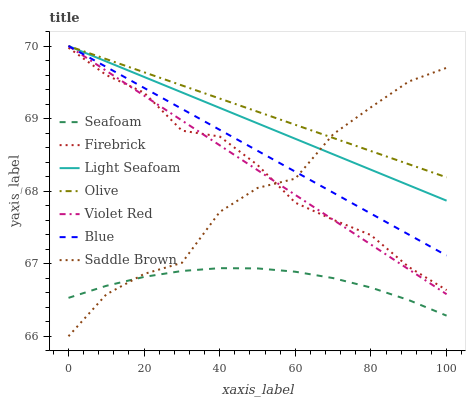Does Seafoam have the minimum area under the curve?
Answer yes or no. Yes. Does Olive have the maximum area under the curve?
Answer yes or no. Yes. Does Violet Red have the minimum area under the curve?
Answer yes or no. No. Does Violet Red have the maximum area under the curve?
Answer yes or no. No. Is Blue the smoothest?
Answer yes or no. Yes. Is Saddle Brown the roughest?
Answer yes or no. Yes. Is Violet Red the smoothest?
Answer yes or no. No. Is Violet Red the roughest?
Answer yes or no. No. Does Violet Red have the lowest value?
Answer yes or no. No. Does Light Seafoam have the highest value?
Answer yes or no. Yes. Does Firebrick have the highest value?
Answer yes or no. No. Is Seafoam less than Olive?
Answer yes or no. Yes. Is Light Seafoam greater than Seafoam?
Answer yes or no. Yes. Does Saddle Brown intersect Blue?
Answer yes or no. Yes. Is Saddle Brown less than Blue?
Answer yes or no. No. Is Saddle Brown greater than Blue?
Answer yes or no. No. Does Seafoam intersect Olive?
Answer yes or no. No. 